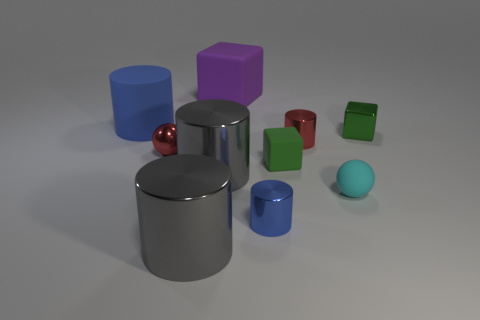What material is the ball that is behind the small cyan ball? The ball behind the small cyan ball appears to be shiny and reflective, suggesting that it is made of a polished metal, possibly chrome or steel, which is commonly used for such objects due to its durability and aesthetic appeal. 